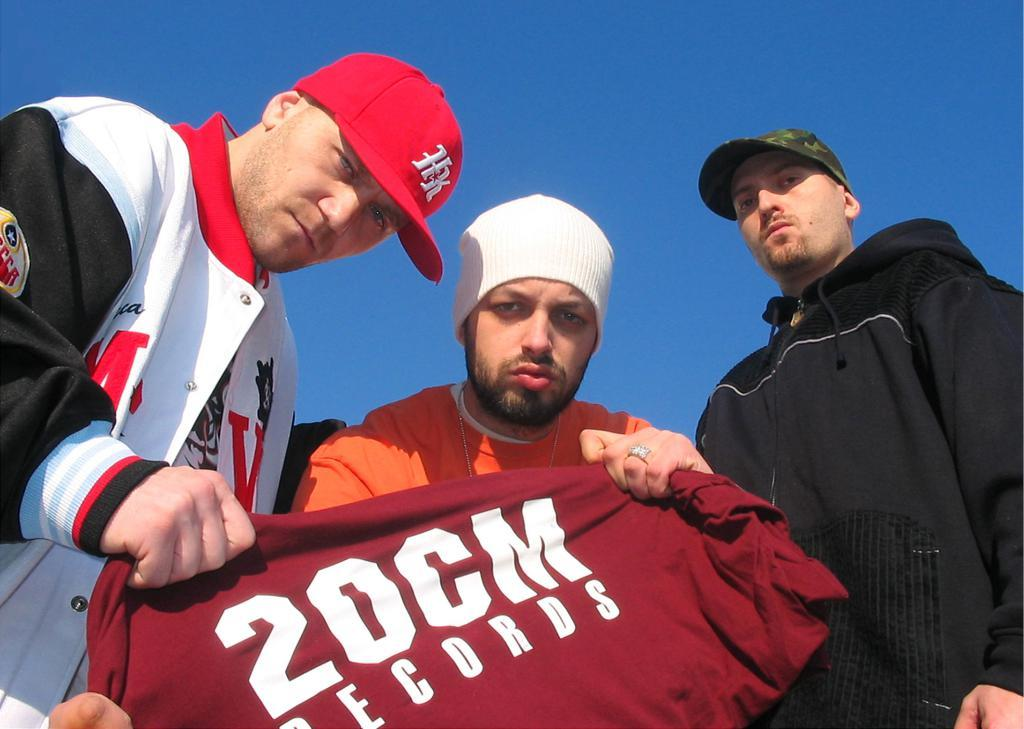Provide a one-sentence caption for the provided image. 3 white man with two of them holding a 2OCM Records shirt in front of them. 